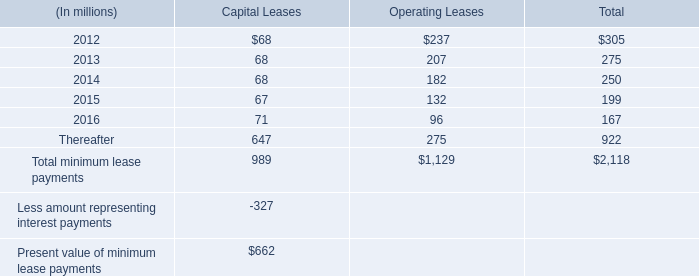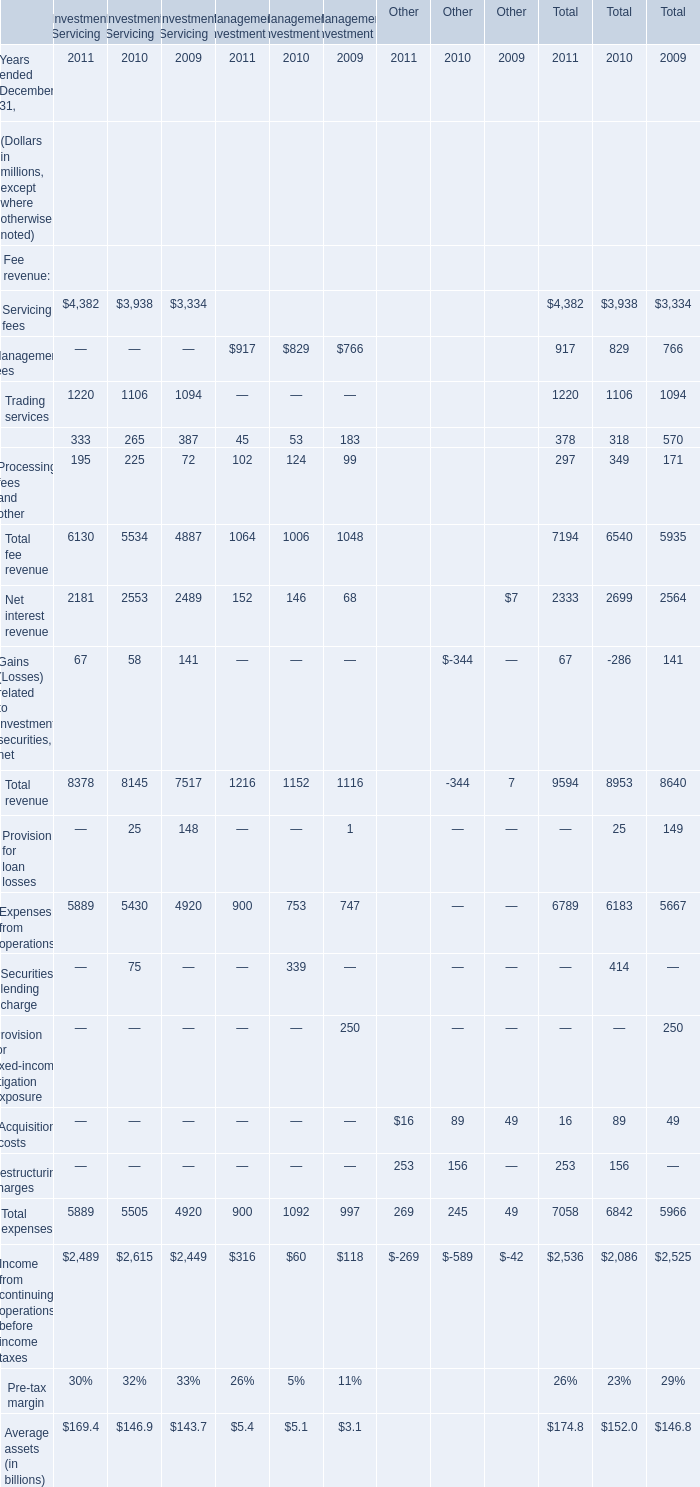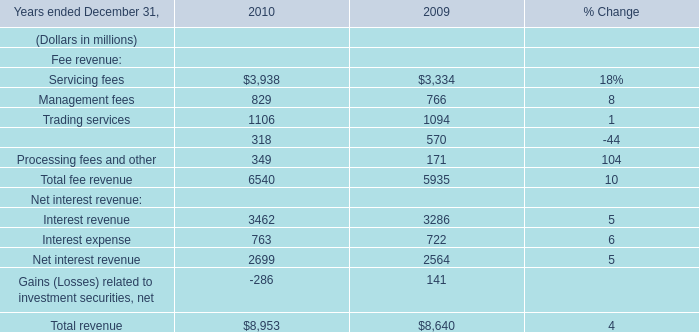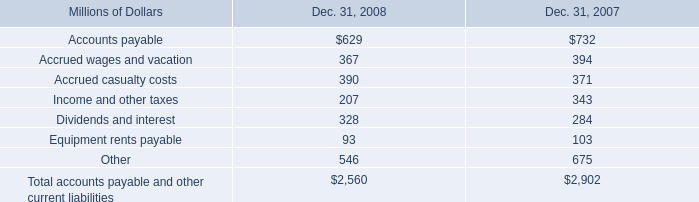What is the sum of the Trading services in the years where Servicing fees is greater than 1 for Investment Servicing? (in million) 
Computations: ((1220 + 1106) + 1094)
Answer: 3420.0. 